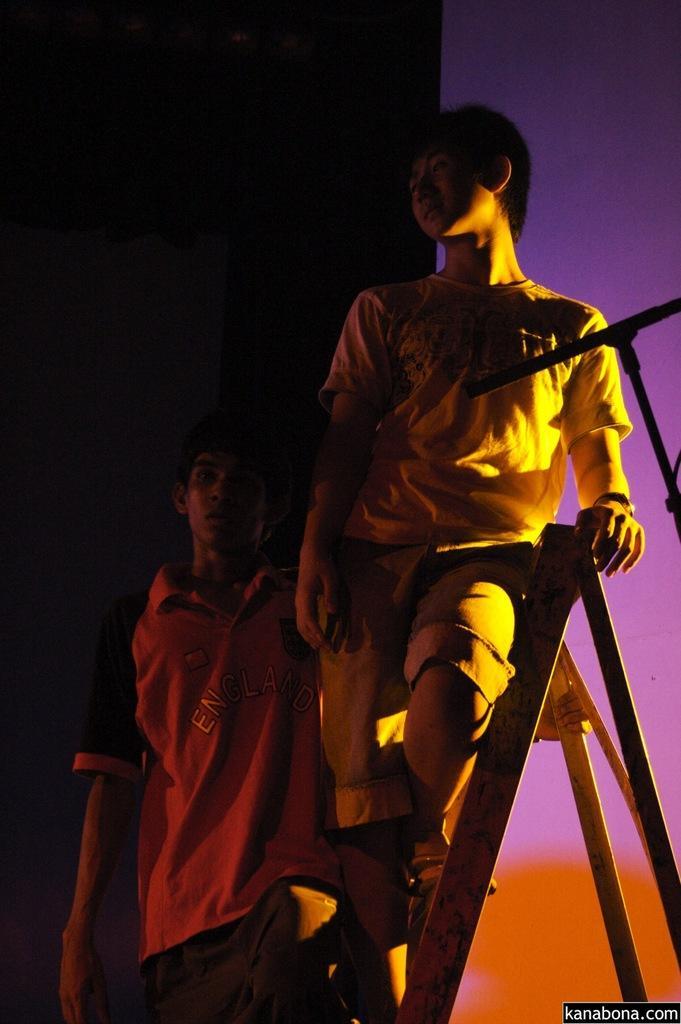Can you describe this image briefly? In this image the background is black, purple and orange in colour. In the middle of the image a boy is sitting on the stool and another boy is standing. On the right side of the image there is an object. 